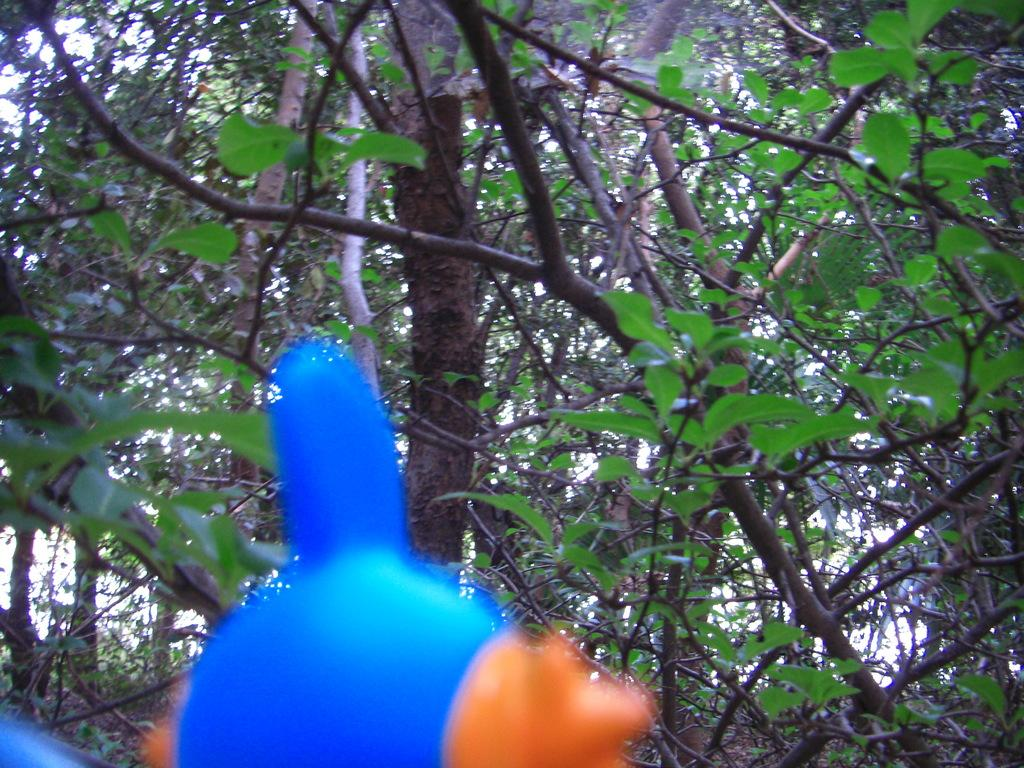What type of plant can be seen in the image? There is a tree in the image. What part of the natural environment is visible in the image? The sky is visible in the image. What object can be found at the bottom of the image? There is a toy on the bottom of the image. What type of pancake can be seen on the tree in the image? There is no pancake present in the image, and the tree does not have any pancakes on it. 